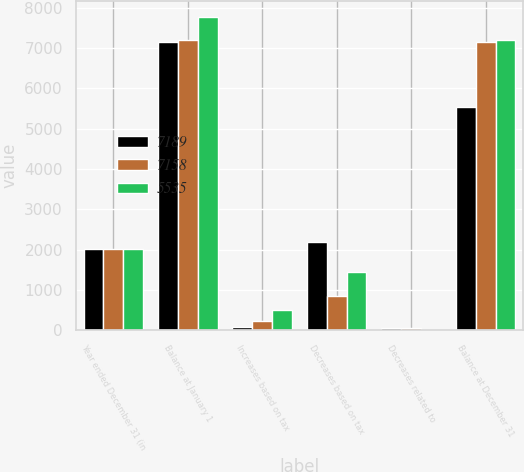Convert chart. <chart><loc_0><loc_0><loc_500><loc_500><stacked_bar_chart><ecel><fcel>Year ended December 31 (in<fcel>Balance at January 1<fcel>Increases based on tax<fcel>Decreases based on tax<fcel>Decreases related to<fcel>Balance at December 31<nl><fcel>7189<fcel>2013<fcel>7158<fcel>88<fcel>2200<fcel>53<fcel>5535<nl><fcel>7158<fcel>2012<fcel>7189<fcel>234<fcel>853<fcel>50<fcel>7158<nl><fcel>5535<fcel>2011<fcel>7767<fcel>496<fcel>1433<fcel>16<fcel>7189<nl></chart> 